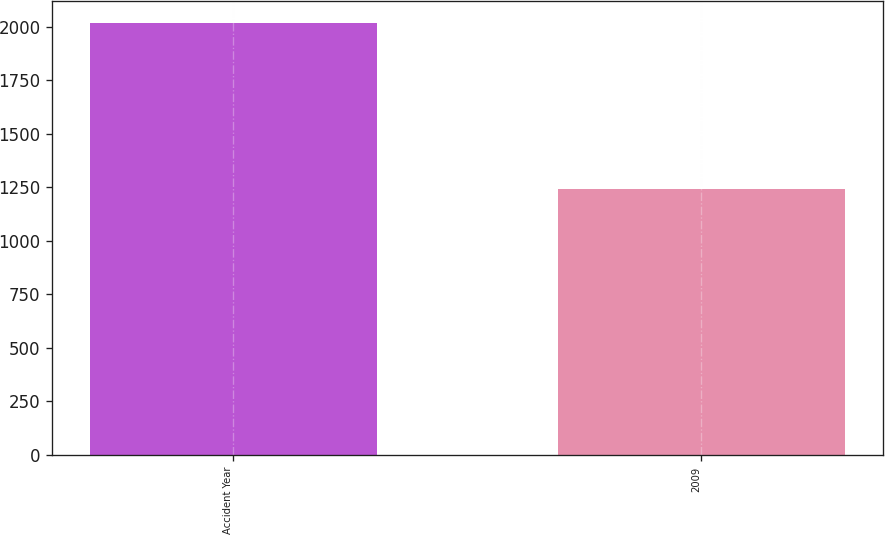<chart> <loc_0><loc_0><loc_500><loc_500><bar_chart><fcel>Accident Year<fcel>2009<nl><fcel>2017<fcel>1242<nl></chart> 